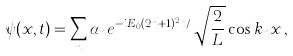<formula> <loc_0><loc_0><loc_500><loc_500>\psi ( x , t ) = \sum _ { n } \alpha _ { n } e ^ { - i E _ { 0 } ( 2 n + 1 ) ^ { 2 } t / } \, \sqrt { \frac { 2 } { L } } \cos { k _ { n } x } \, ,</formula> 